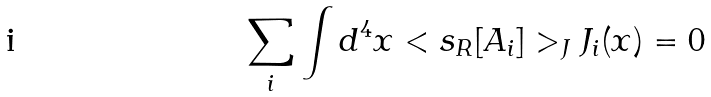Convert formula to latex. <formula><loc_0><loc_0><loc_500><loc_500>\sum _ { i } \int d ^ { 4 } x < s _ { R } [ A _ { i } ] > _ { J } J _ { i } ( x ) = 0</formula> 